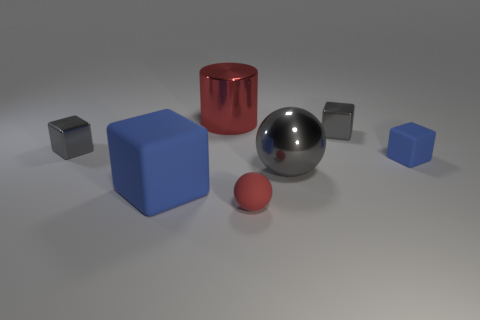Add 2 red rubber objects. How many objects exist? 9 Subtract all spheres. How many objects are left? 5 Add 4 tiny blue rubber blocks. How many tiny blue rubber blocks exist? 5 Subtract 1 gray spheres. How many objects are left? 6 Subtract all red matte things. Subtract all tiny rubber balls. How many objects are left? 5 Add 3 small metal blocks. How many small metal blocks are left? 5 